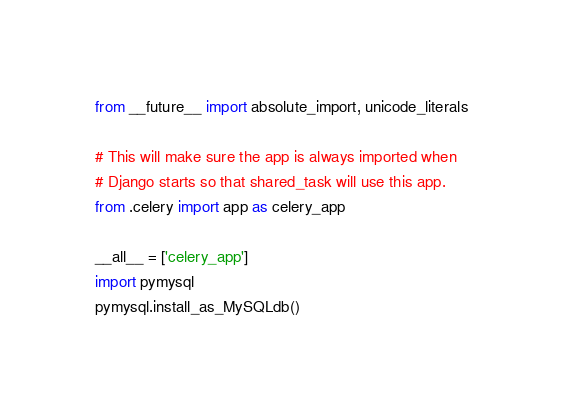Convert code to text. <code><loc_0><loc_0><loc_500><loc_500><_Python_>from __future__ import absolute_import, unicode_literals

# This will make sure the app is always imported when
# Django starts so that shared_task will use this app.
from .celery import app as celery_app

__all__ = ['celery_app']
import pymysql
pymysql.install_as_MySQLdb()
</code> 